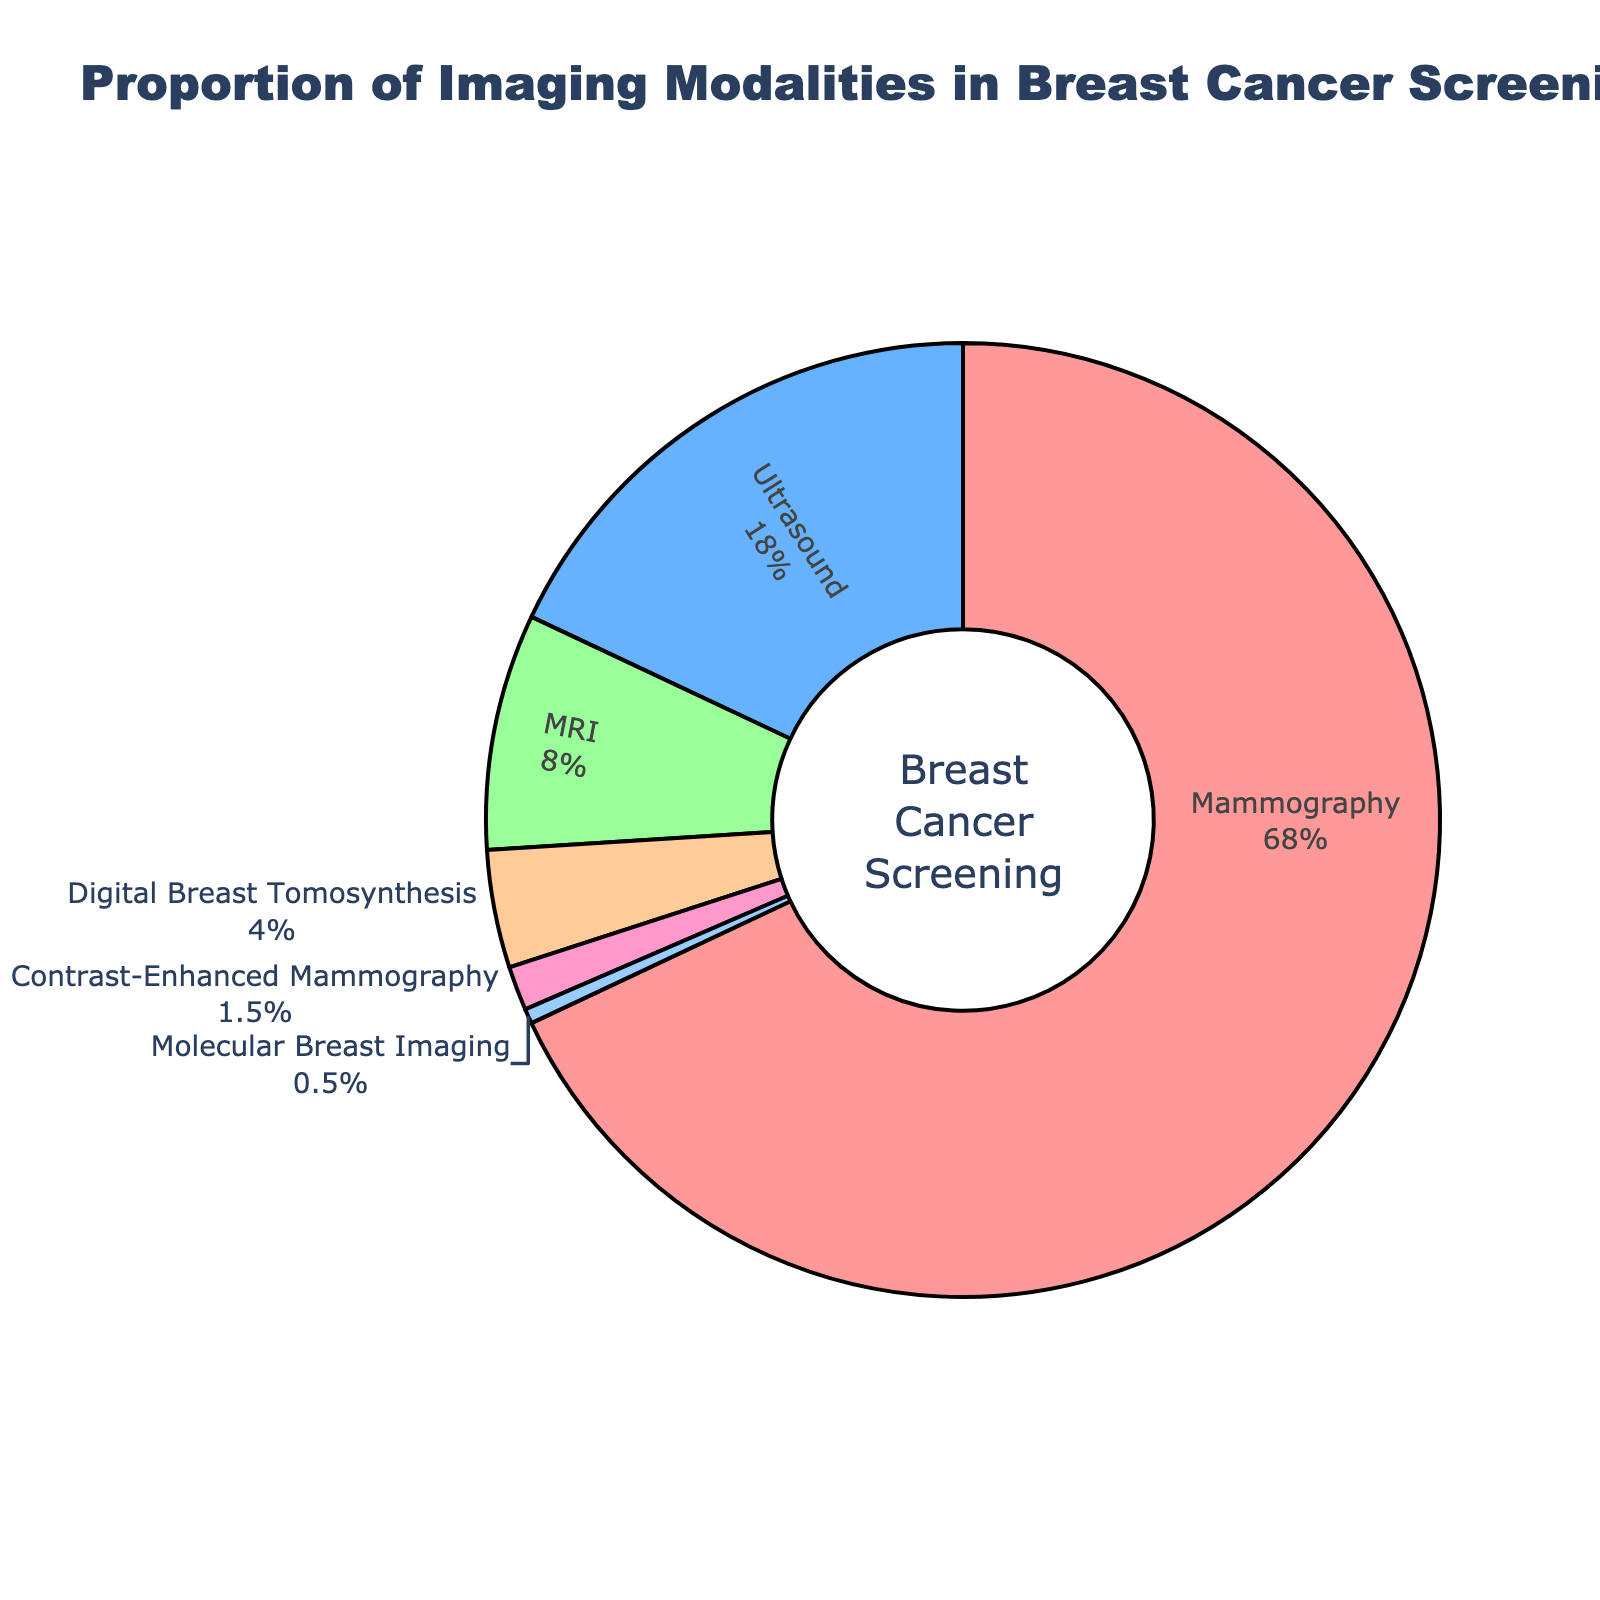What is the proportion of Mammography in breast cancer screening? Mammography's proportion is directly labeled in the pie chart, displaying its percentage clearly.
Answer: 68% Which imaging modality has the smallest usage in breast cancer screening? By examining the pie chart, the smallest segment with the label indicating its proportion is Molecular Breast Imaging.
Answer: Molecular Breast Imaging What is the combined percentage of MRI and Digital Breast Tomosynthesis? MRI has 8%, and Digital Breast Tomosynthesis has 4%. Adding these two percentages together gives us 8% + 4% = 12%.
Answer: 12% Compare the usage of Ultrasound with MRI. Which one is used more and by how much? Ultrasound has 18%, and MRI has 8%. The difference in their usage is 18% - 8% = 10%. Thus, Ultrasound is used 10% more than MRI.
Answer: Ultrasound by 10% If we consider the combined usage of Contrast-Enhanced Mammography and Molecular Breast Imaging, what is their total percentage? Contrast-Enhanced Mammography has 1.5%, and Molecular Breast Imaging has 0.5%. Their combined usage adds up to 1.5% + 0.5% = 2%.
Answer: 2% Which imaging modalities constitute less than 10% of the total usage each? The pie chart shows percentages for each category. Both Digital Breast Tomosynthesis (4%), Contrast-Enhanced Mammography (1.5%), and Molecular Breast Imaging (0.5%) each have percentages under 10%.
Answer: Digital Breast Tomosynthesis, Contrast-Enhanced Mammography, Molecular Breast Imaging What is the difference in proportion between Mammography and all other modalities combined? Mammography is 68%. The other modalities add up to 18% (Ultrasound) + 8% (MRI) + 4% (Digital Breast Tomosynthesis) + 1.5% (Contrast-Enhanced Mammography) + 0.5% (Molecular Breast Imaging) = 32%. The difference is 68% - 32% = 36%.
Answer: 36% According to the pie chart, what percentage share do MRI and Contrast-Enhanced Mammography together hold? MRI is 8%, and Contrast-Enhanced Mammography is 1.5%. Combining these, 8% + 1.5% = 9.5%.
Answer: 9.5% 